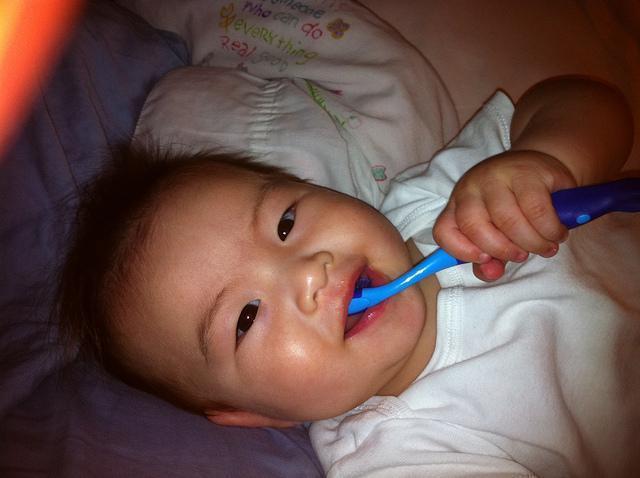How many couches are there?
Give a very brief answer. 1. How many birds are in the photo?
Give a very brief answer. 0. 